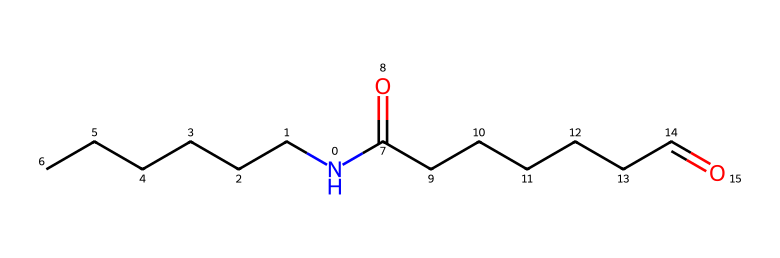What is the total number of carbon atoms in this molecule? The SMILES representation shows a total of 12 carbon atoms (CCCCCC and C(=O)CCCCCC), which can be counted directly from the structure.
Answer: twelve How many nitrogen atoms are present in this molecule? The SMILES shows one nitrogen atom (N), as indicated at the beginning of the structure.
Answer: one What type of functional group is present in this compound? The presence of C(=O) indicates a carbonyl functional group (specifically amide groups in this structure), which is characteristic of polyamides like nylon.
Answer: amide What is the degree of polymerization indicated by the structure? The structure represents a typical monomer that can lead to a repeating unit in a polymer chain when polymerized, indicating a degree of polymerization of one (as it is a single monomer).
Answer: one Can this chemical form hydrogen bonds? The presence of both nitrogen (N) and oxygen (O) atoms indicates the possibility of hydrogen bonding due to the electronegative nature of these elements, which can participate in bonding.
Answer: yes What type of polymer is formed from this monomer? This monomer corresponds to polyamides (like nylon) due to the amide linkages in the structure once polymerization occurs.
Answer: polyamide Does this chemical represent a branching structure? The SMILES does not show any branching points; all chains are linear without any substituent groups, thus representing a linear structure.
Answer: no 